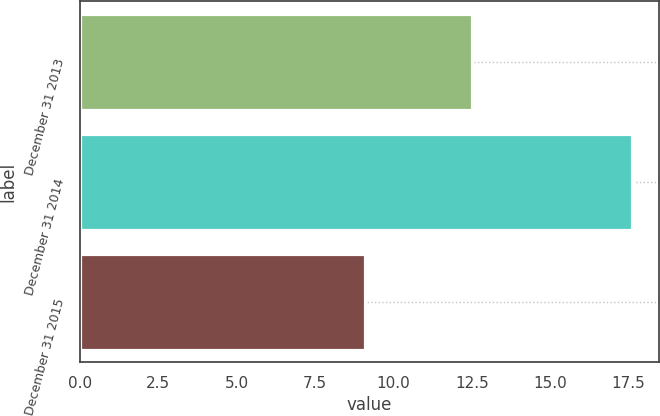Convert chart to OTSL. <chart><loc_0><loc_0><loc_500><loc_500><bar_chart><fcel>December 31 2013<fcel>December 31 2014<fcel>December 31 2015<nl><fcel>12.5<fcel>17.6<fcel>9.1<nl></chart> 